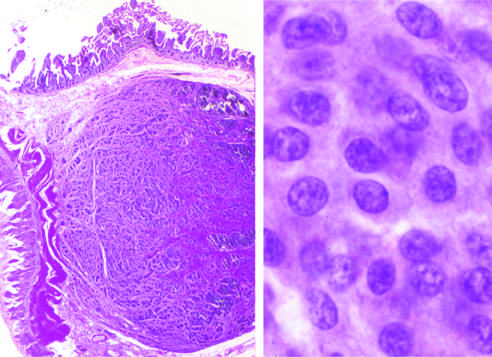what does high magnification show?
Answer the question using a single word or phrase. The bland cytology that typifies neuroendocrine tumors 